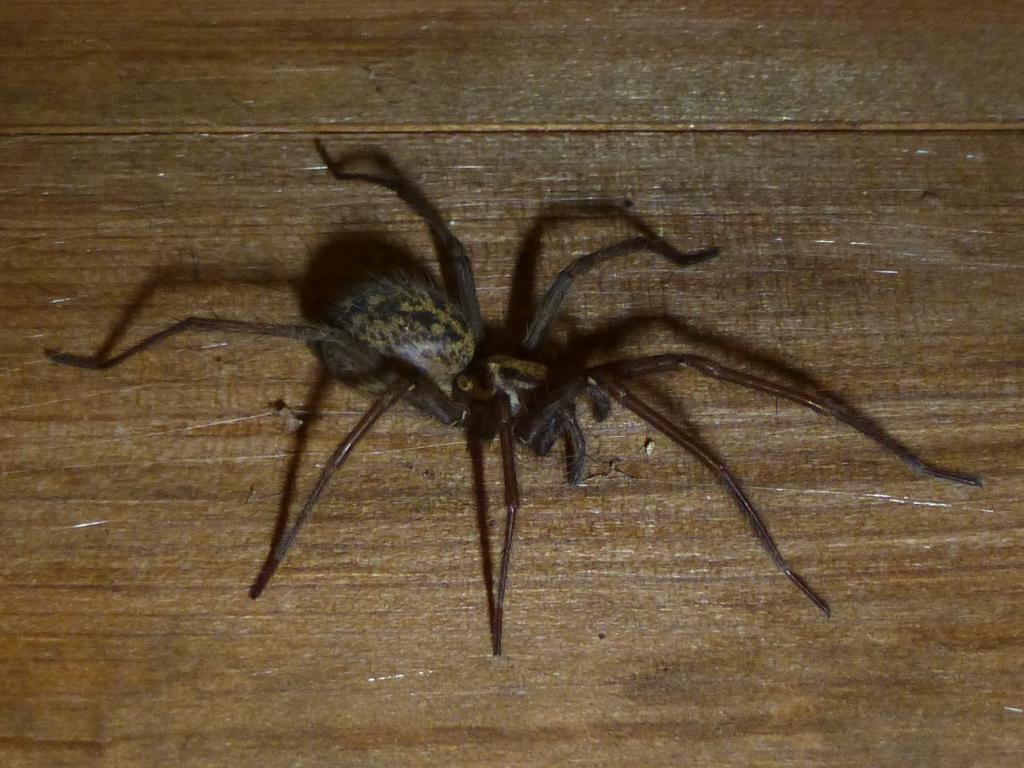In one or two sentences, can you explain what this image depicts? In this picture, we see the spider. It is in black color. In the background, we see a brown table or a wooden wall. 